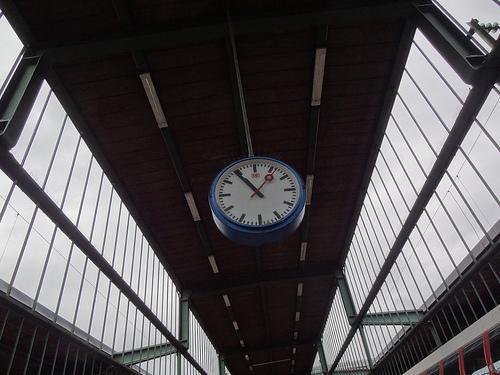How many clocks?
Give a very brief answer. 1. 